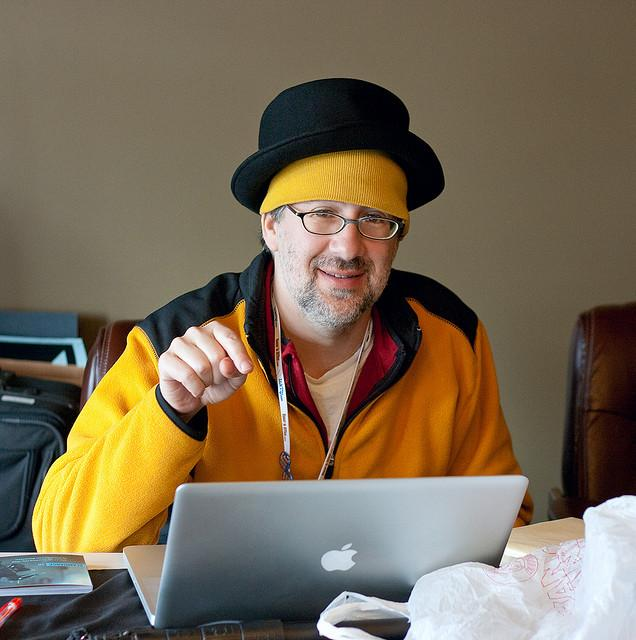What is the man's hat called? top hat 